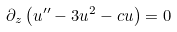<formula> <loc_0><loc_0><loc_500><loc_500>\partial _ { z } \left ( u ^ { \prime \prime } - 3 u ^ { 2 } - c u \right ) = 0</formula> 